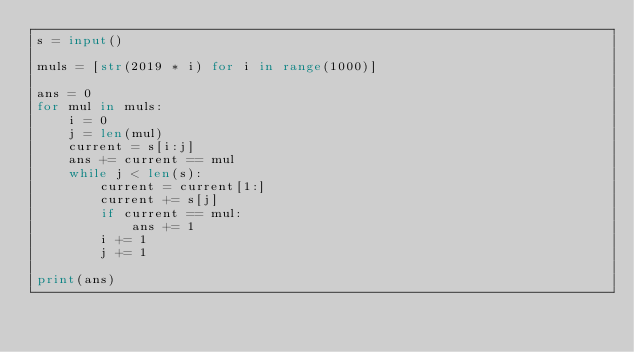<code> <loc_0><loc_0><loc_500><loc_500><_Python_>s = input()

muls = [str(2019 * i) for i in range(1000)]

ans = 0
for mul in muls:
    i = 0
    j = len(mul)
    current = s[i:j]
    ans += current == mul
    while j < len(s):
        current = current[1:]
        current += s[j]
        if current == mul:
            ans += 1
        i += 1
        j += 1

print(ans)
</code> 